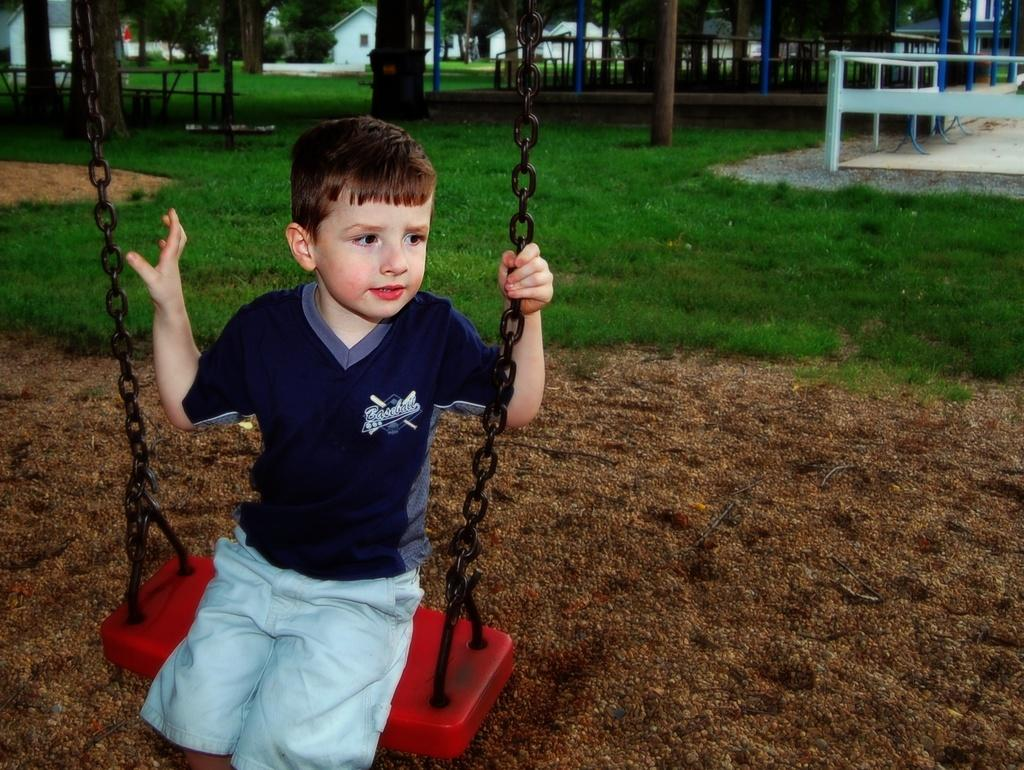Who is the main subject in the image? There is a boy in the image. What is the boy doing in the image? The boy is sitting on a swing. What can be seen in the background of the image? There are trees, benches, a boundary, and buildings in the background of the image. What type of finger design can be seen on the boy's hand in the image? There is no finger design mentioned or visible in the image; the focus is on the boy sitting on a swing and the background elements. 